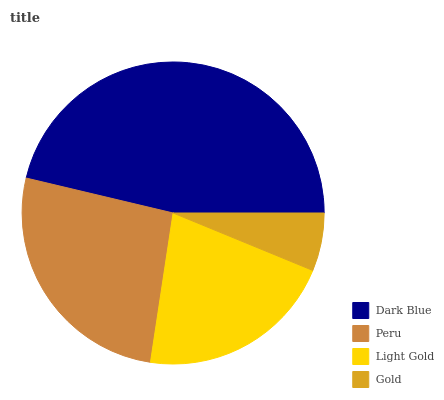Is Gold the minimum?
Answer yes or no. Yes. Is Dark Blue the maximum?
Answer yes or no. Yes. Is Peru the minimum?
Answer yes or no. No. Is Peru the maximum?
Answer yes or no. No. Is Dark Blue greater than Peru?
Answer yes or no. Yes. Is Peru less than Dark Blue?
Answer yes or no. Yes. Is Peru greater than Dark Blue?
Answer yes or no. No. Is Dark Blue less than Peru?
Answer yes or no. No. Is Peru the high median?
Answer yes or no. Yes. Is Light Gold the low median?
Answer yes or no. Yes. Is Dark Blue the high median?
Answer yes or no. No. Is Peru the low median?
Answer yes or no. No. 